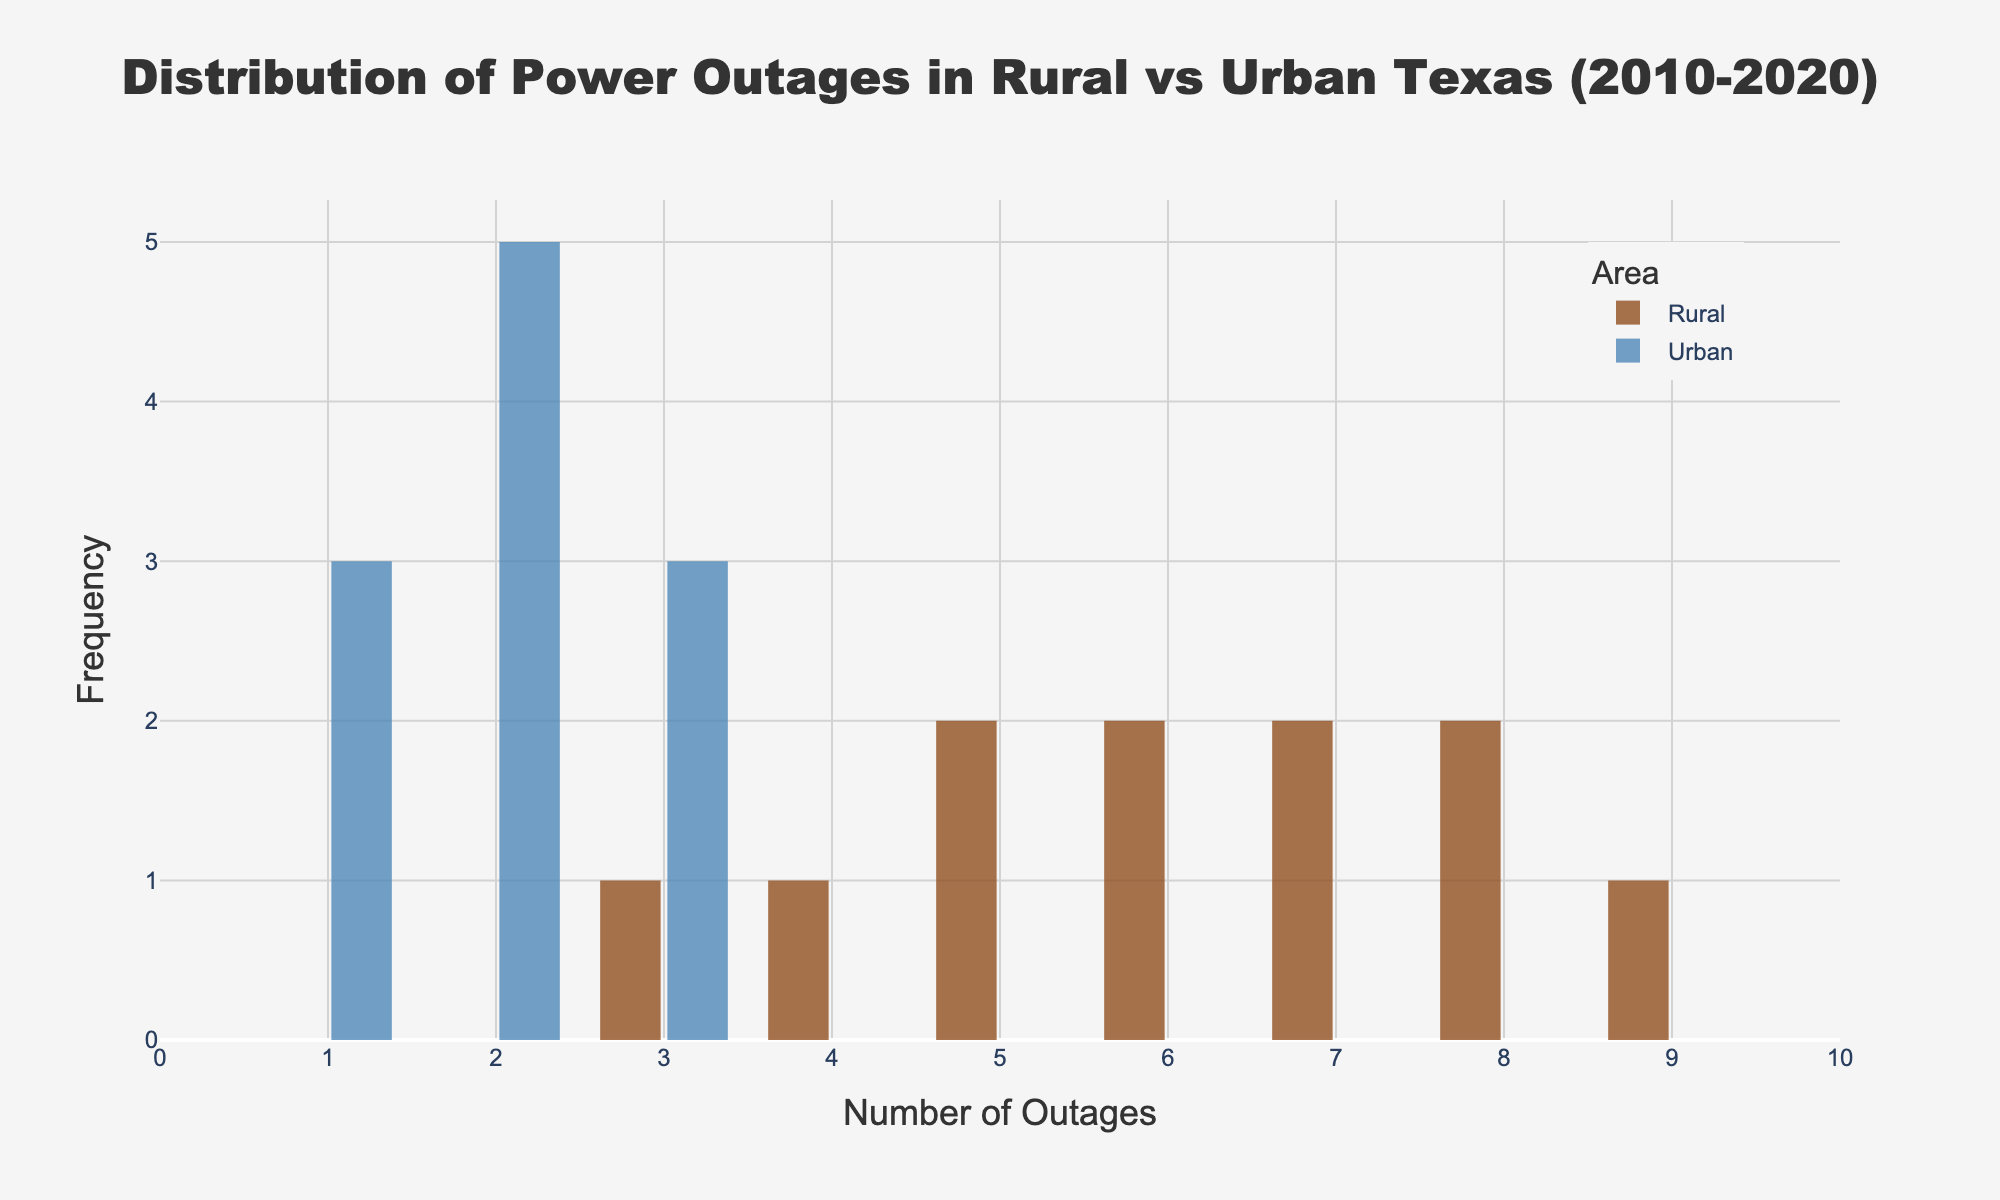Which area has a higher frequency of power outages? By looking at the histograms, the Rural area has higher frequencies for higher numbers of outages compared to the Urban area.
Answer: Rural What is the title of the plot? The title is found at the top and it summarizes the plot content. It reads: "Distribution of Power Outages in Rural vs Urban Texas (2010-2020)".
Answer: Distribution of Power Outages in Rural vs Urban Texas (2010-2020) How many bins are used to categorize the number of outages? The histograms are categorized into bins, each representing an interval of data. The plot uses 10 bins for both Rural and Urban areas.
Answer: 10 What is the maximum number of outages observed in both areas? By observing the x-axis range, the maximum number of outages plotted for each area is 10.
Answer: 10 What color represents Urban area outages in the plot? The color designation for Urban area outages is observed in the legend of the plot, which shows it as blue.
Answer: Blue Which year had the highest number of outages in Rural areas? By viewing the distribution, the highest bin for Rural areas corresponds to 9 outages, and this was in 2019.
Answer: 2019 On average, which area has more power outages? Calculate the mean value for each area. The sum of outages for Rural is 68 over 11 years, giving an average of 6.18. The sum for Urban is 22 over 11 years, giving an average of 2.
Answer: Rural Are there any years where both Rural and Urban areas had the same number of outages? By comparing exact values visually, 2012 and 2015 both had 3 outages in both Rural and Urban areas.
Answer: Yes, 2012 and 2015 How do the frequencies of 3 outages compare between Rural and Urban areas? Look at the histograms to see where the bar heights align for three outages. There is one instance of 3 outages in both regions.
Answer: They are equal Which year saw the least number of outages in Urban areas? Observing the bins, the smallest frequencies for Urban include 1 outage/year, which occurred in 2011, 2014, and 2017.
Answer: 2011, 2014, and 2017 